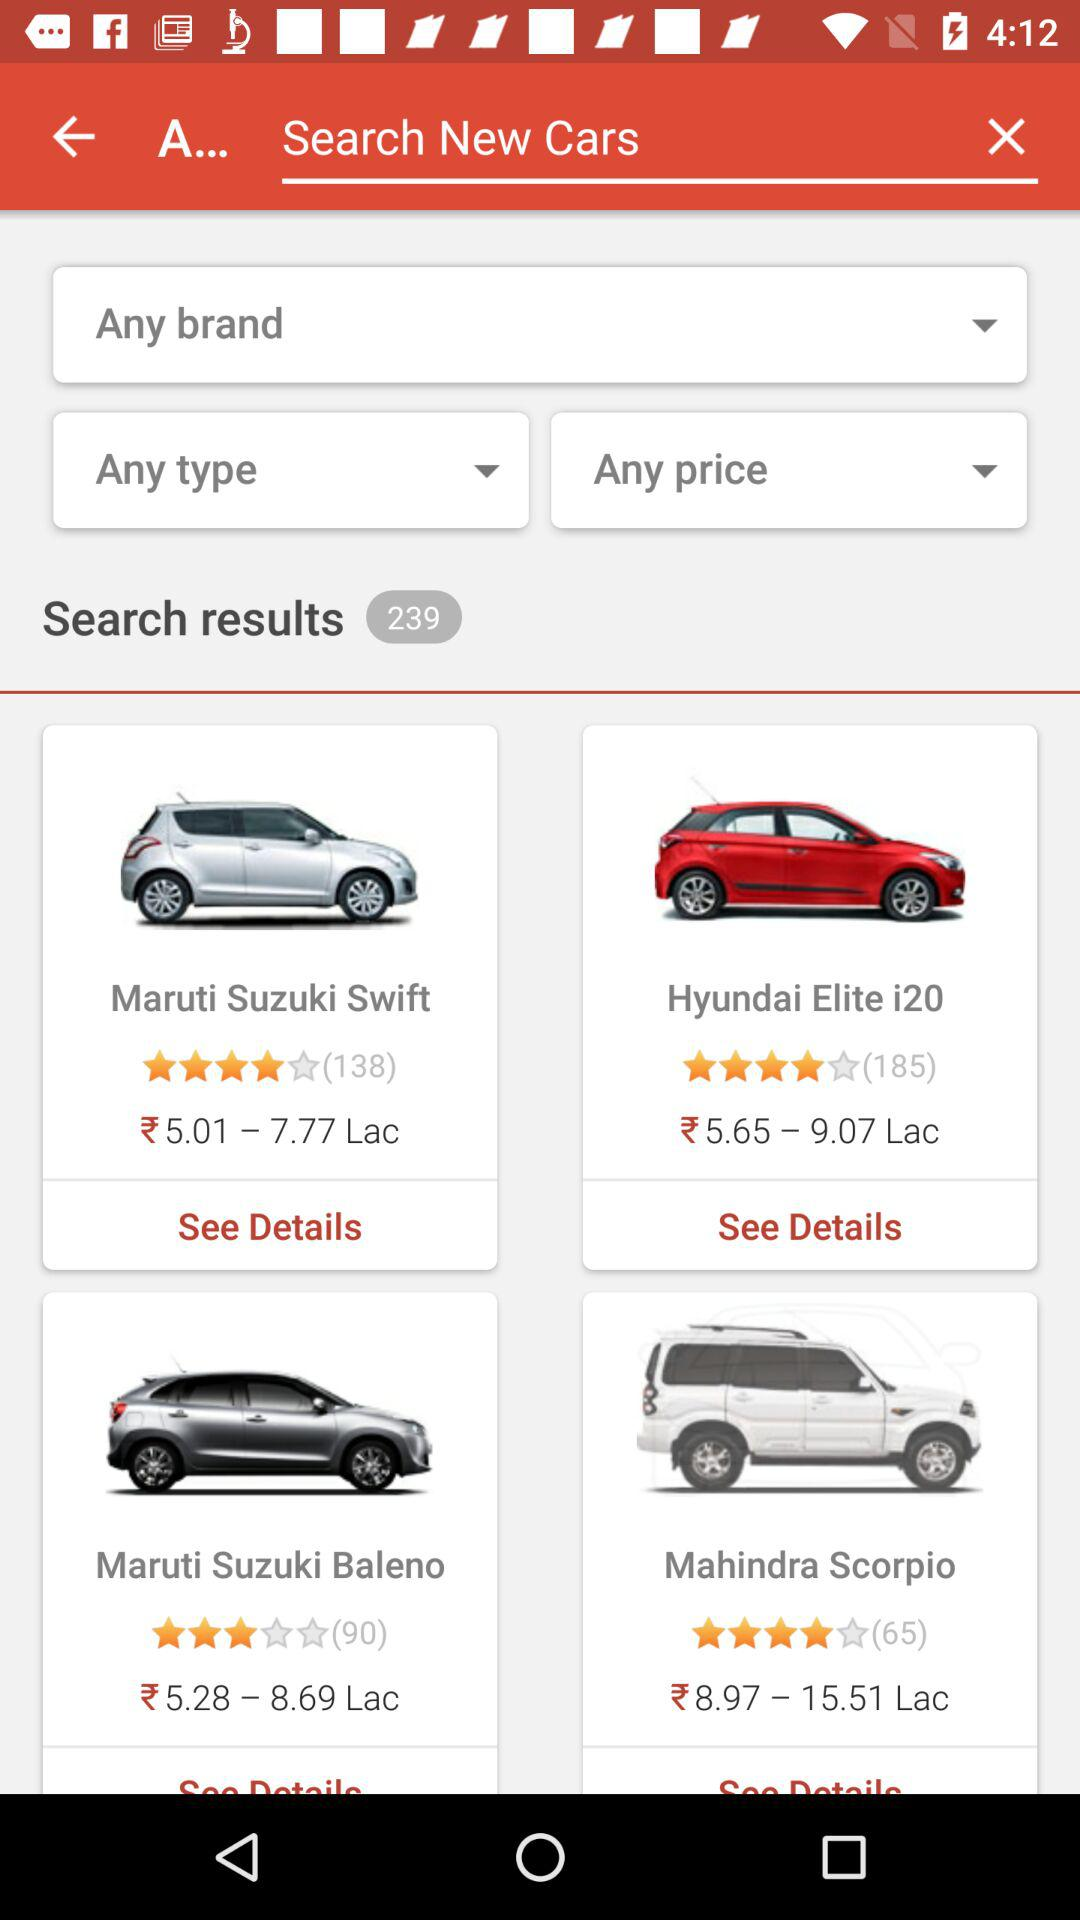What are the ratings for the Maruti Suzuki Baleno? The rating is 3 stars. 